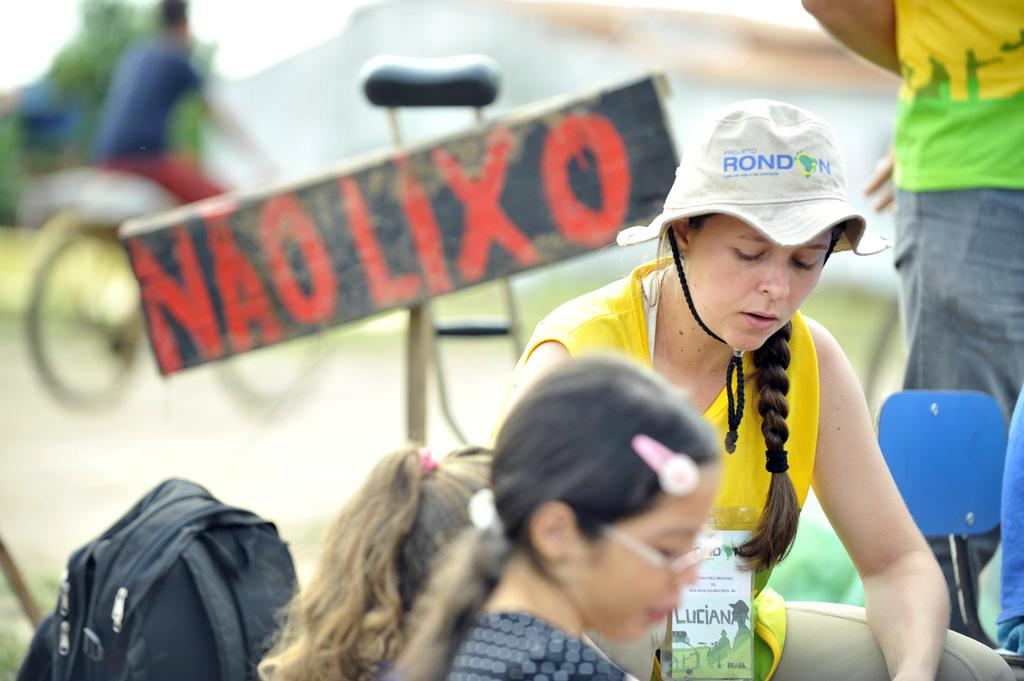How many people are in the image? There are persons in the image, but the exact number is not specified. What object can be seen in the image besides the persons? There is a bag and a board with alphabets in the image. Can you describe the board in the image? The board has alphabets on it. What is the background of the image like? The background of the image is blurred. How many sheep are visible in the image? There are no sheep present in the image. What type of dime is being used to play the game on the board? There is no game or dime mentioned in the image; it only features a board with alphabets. 